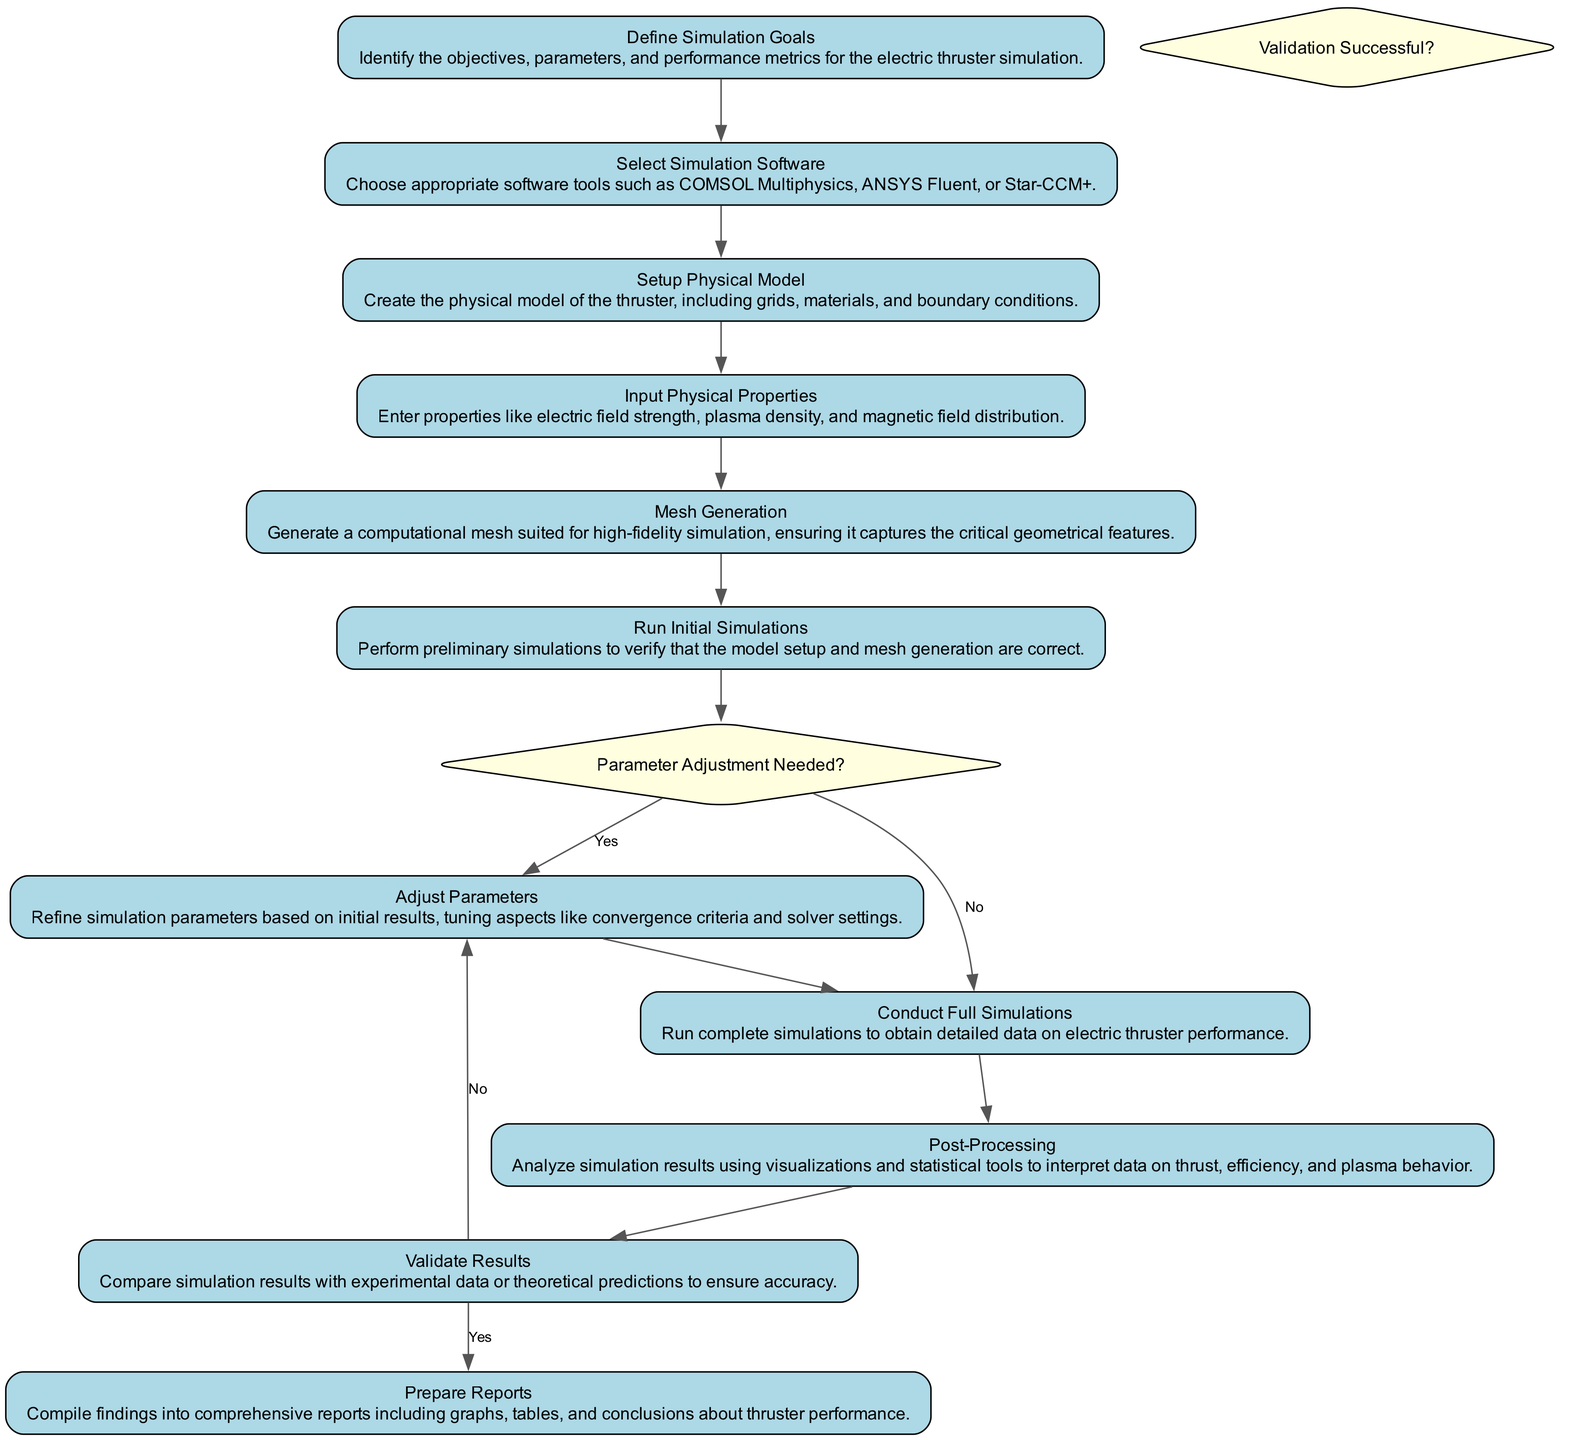What is the first activity in the diagram? The first activity in the diagram is "Define Simulation Goals." This is the starting point before moving to any other activities, as indicated by the transitions.
Answer: Define Simulation Goals How many decision points are present in the diagram? There are two decision points: "Parameter Adjustment Needed?" and "Validation Successful?" These specific points determine the flow based on the outcomes of simulations.
Answer: 2 What happens after conducting full simulations? After conducting full simulations, the next step is "Post-Processing." This signifies that the simulation should be fully completed before analysis can take place.
Answer: Post-Processing What condition leads to "Adjust Parameters" being revisited? The condition that leads to revisiting "Adjust Parameters" is the answer "No" to the question "Parameter Adjustment Needed?" This means that based on initial or full simulation results, parameters are not adjusted further.
Answer: No Which activity requires inputting physical properties? The activity that requires inputting physical properties is "Input Physical Properties." This activity follows "Setup Physical Model" and involves entering crucial data for the simulation.
Answer: Input Physical Properties What sequence occurs if validation is unsuccessful? If validation is unsuccessful, the flow moves back to "Adjust Parameters." This means that the results do not align with expectations, necessitating further adjustments.
Answer: Adjust Parameters Which activities do not have outgoing transitions? The activities "Define Simulation Goals" and "Validate Results" do not have any outgoing transitions in terms of leading directly to another step since they define starting or end points in the process.
Answer: Define Simulation Goals, Validate Results What is the last activity in the flow? The last activity in the flow is "Prepare Reports." This concludes the entire process of simulation, validation, and result analysis.
Answer: Prepare Reports 